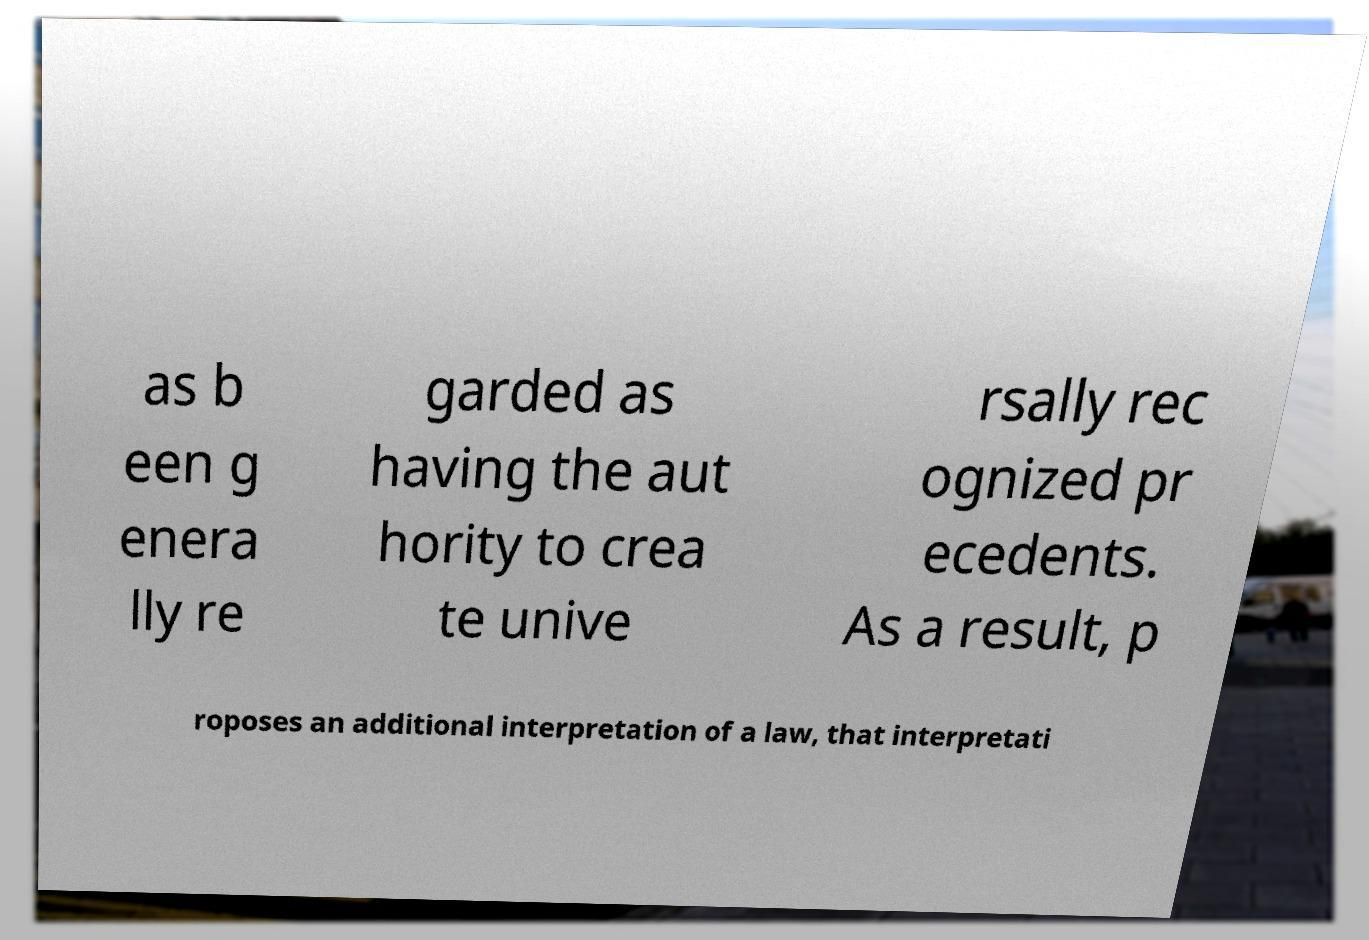Please identify and transcribe the text found in this image. as b een g enera lly re garded as having the aut hority to crea te unive rsally rec ognized pr ecedents. As a result, p roposes an additional interpretation of a law, that interpretati 